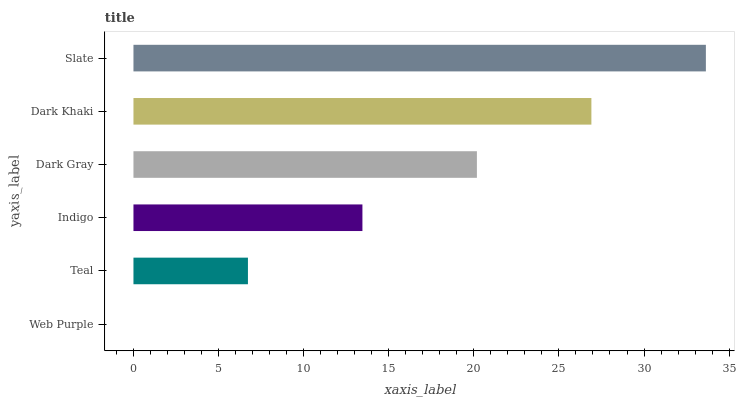Is Web Purple the minimum?
Answer yes or no. Yes. Is Slate the maximum?
Answer yes or no. Yes. Is Teal the minimum?
Answer yes or no. No. Is Teal the maximum?
Answer yes or no. No. Is Teal greater than Web Purple?
Answer yes or no. Yes. Is Web Purple less than Teal?
Answer yes or no. Yes. Is Web Purple greater than Teal?
Answer yes or no. No. Is Teal less than Web Purple?
Answer yes or no. No. Is Dark Gray the high median?
Answer yes or no. Yes. Is Indigo the low median?
Answer yes or no. Yes. Is Indigo the high median?
Answer yes or no. No. Is Dark Khaki the low median?
Answer yes or no. No. 